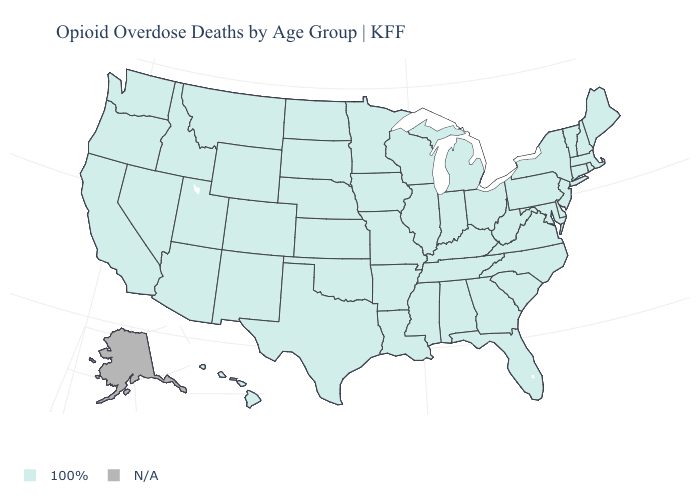How many symbols are there in the legend?
Be succinct. 2. Name the states that have a value in the range 100%?
Short answer required. Alabama, Arizona, Arkansas, California, Colorado, Connecticut, Delaware, Florida, Georgia, Hawaii, Idaho, Illinois, Indiana, Iowa, Kansas, Kentucky, Louisiana, Maine, Maryland, Massachusetts, Michigan, Minnesota, Mississippi, Missouri, Montana, Nebraska, Nevada, New Hampshire, New Jersey, New Mexico, New York, North Carolina, North Dakota, Ohio, Oklahoma, Oregon, Pennsylvania, Rhode Island, South Carolina, South Dakota, Tennessee, Texas, Utah, Vermont, Virginia, Washington, West Virginia, Wisconsin, Wyoming. Does the first symbol in the legend represent the smallest category?
Answer briefly. No. Name the states that have a value in the range 100%?
Short answer required. Alabama, Arizona, Arkansas, California, Colorado, Connecticut, Delaware, Florida, Georgia, Hawaii, Idaho, Illinois, Indiana, Iowa, Kansas, Kentucky, Louisiana, Maine, Maryland, Massachusetts, Michigan, Minnesota, Mississippi, Missouri, Montana, Nebraska, Nevada, New Hampshire, New Jersey, New Mexico, New York, North Carolina, North Dakota, Ohio, Oklahoma, Oregon, Pennsylvania, Rhode Island, South Carolina, South Dakota, Tennessee, Texas, Utah, Vermont, Virginia, Washington, West Virginia, Wisconsin, Wyoming. What is the highest value in the USA?
Quick response, please. 100%. What is the value of Wyoming?
Short answer required. 100%. Name the states that have a value in the range 100%?
Be succinct. Alabama, Arizona, Arkansas, California, Colorado, Connecticut, Delaware, Florida, Georgia, Hawaii, Idaho, Illinois, Indiana, Iowa, Kansas, Kentucky, Louisiana, Maine, Maryland, Massachusetts, Michigan, Minnesota, Mississippi, Missouri, Montana, Nebraska, Nevada, New Hampshire, New Jersey, New Mexico, New York, North Carolina, North Dakota, Ohio, Oklahoma, Oregon, Pennsylvania, Rhode Island, South Carolina, South Dakota, Tennessee, Texas, Utah, Vermont, Virginia, Washington, West Virginia, Wisconsin, Wyoming. Which states hav the highest value in the South?
Answer briefly. Alabama, Arkansas, Delaware, Florida, Georgia, Kentucky, Louisiana, Maryland, Mississippi, North Carolina, Oklahoma, South Carolina, Tennessee, Texas, Virginia, West Virginia. Is the legend a continuous bar?
Answer briefly. No. Is the legend a continuous bar?
Keep it brief. No. Which states have the lowest value in the MidWest?
Give a very brief answer. Illinois, Indiana, Iowa, Kansas, Michigan, Minnesota, Missouri, Nebraska, North Dakota, Ohio, South Dakota, Wisconsin. Name the states that have a value in the range N/A?
Be succinct. Alaska. What is the value of Wyoming?
Concise answer only. 100%. 